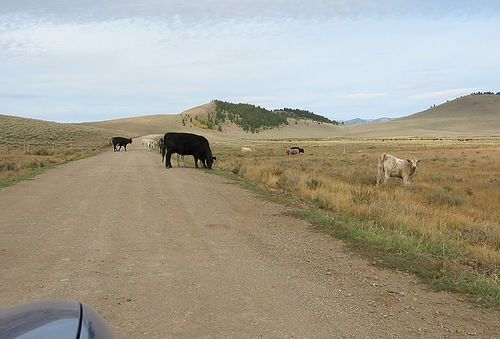Describe the objects in this image and their specific colors. I can see car in darkgray and gray tones, cow in darkgray, black, gray, and darkgreen tones, cow in darkgray, tan, and gray tones, cow in darkgray, black, and gray tones, and cow in darkgray, gray, maroon, black, and tan tones in this image. 